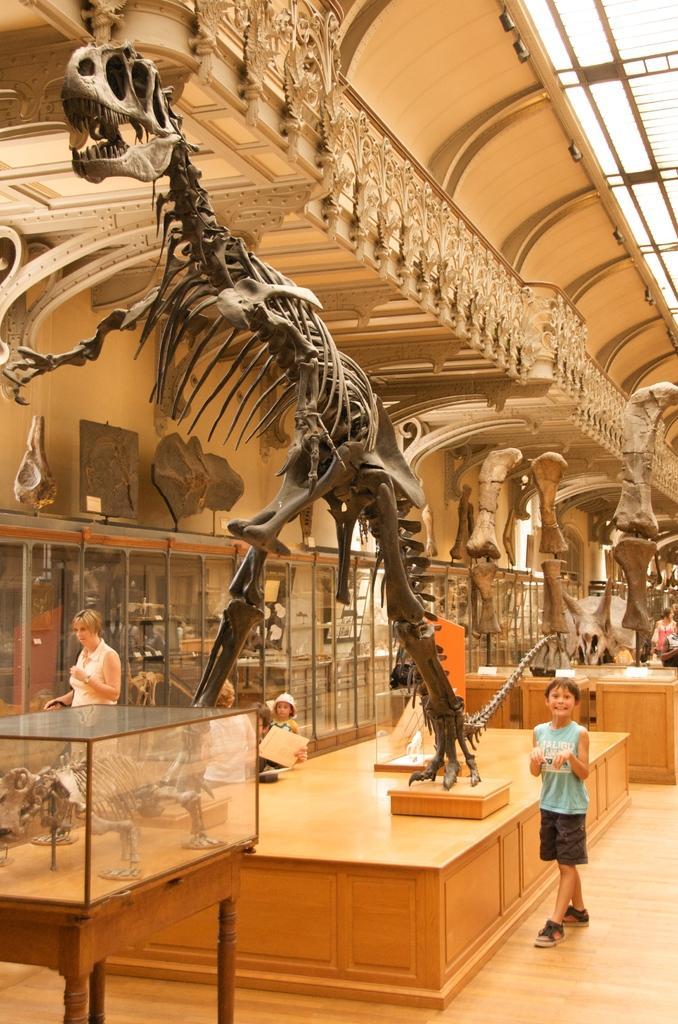Can you describe this image briefly? In the middle of the image there is a dragon skeleton. Bottom right side of the image there is a boy standing beside the table. Bottom left side of the image few persons standing beside the wall. At the top of the image there is a roof. 